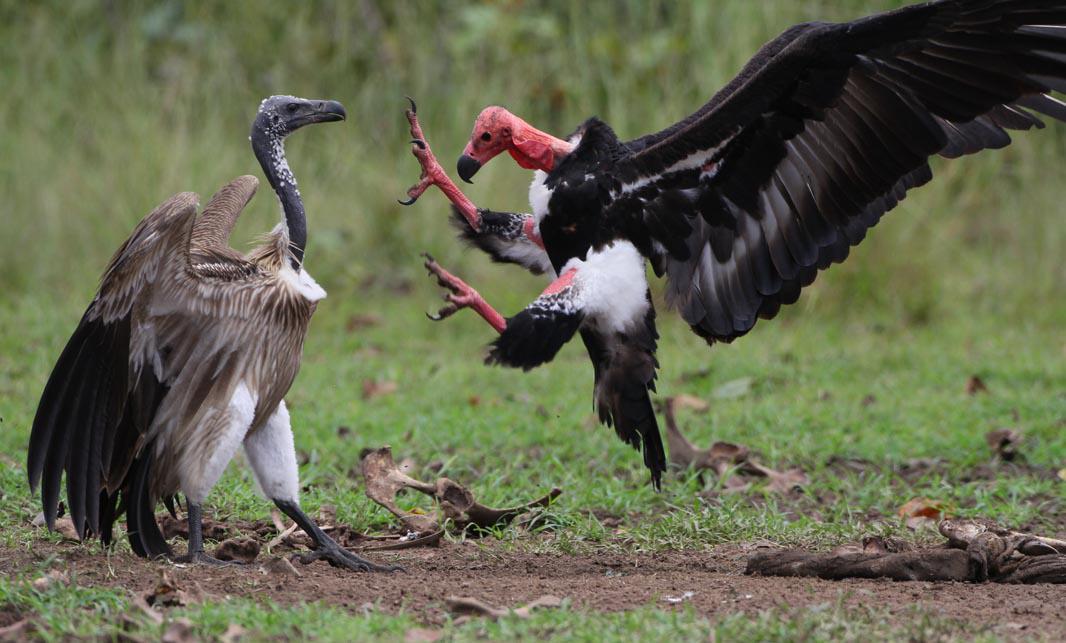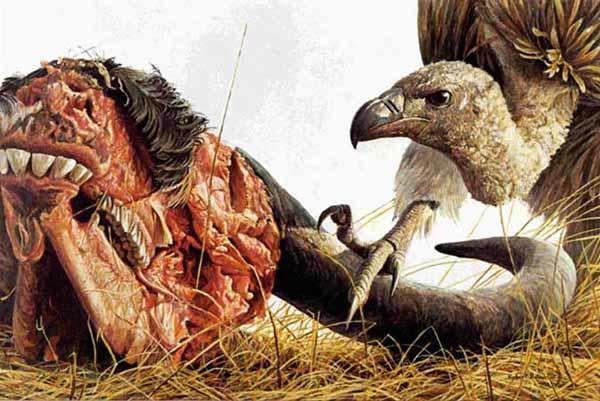The first image is the image on the left, the second image is the image on the right. Analyze the images presented: Is the assertion "Overlapping vultures face opposite directions in the center of one image, which has a brown background." valid? Answer yes or no. No. The first image is the image on the left, the second image is the image on the right. Evaluate the accuracy of this statement regarding the images: "One of the birds appears to have two heads in one of the images.". Is it true? Answer yes or no. No. 